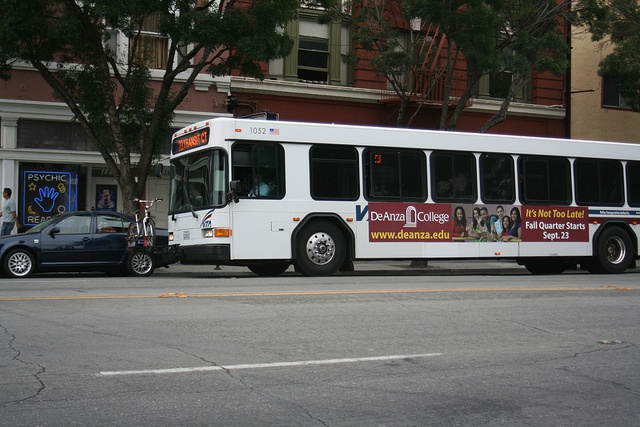Describe the objects in this image and their specific colors. I can see bus in black, lightgray, darkgray, and maroon tones, car in black and gray tones, bicycle in black, gray, maroon, and darkgray tones, people in black, gray, and darkgray tones, and people in black and teal tones in this image. 